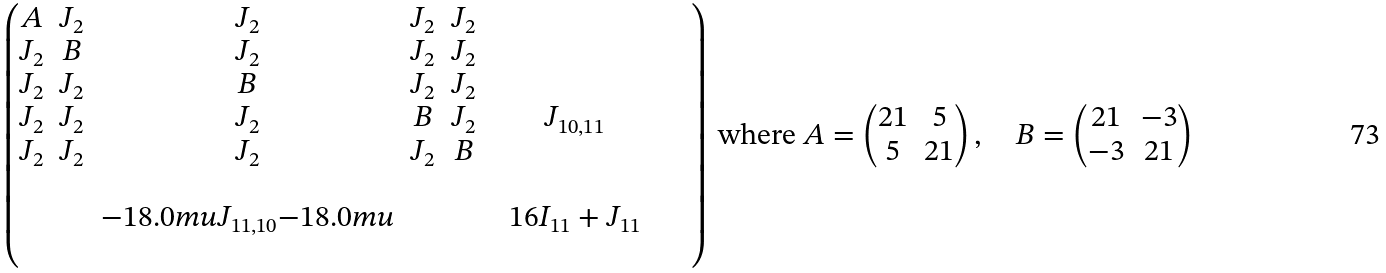Convert formula to latex. <formula><loc_0><loc_0><loc_500><loc_500>\begin{pmatrix} A & J _ { 2 } & J _ { 2 } & J _ { 2 } & J _ { 2 } & & & \\ J _ { 2 } & B & J _ { 2 } & J _ { 2 } & J _ { 2 } & & & \\ J _ { 2 } & J _ { 2 } & B & J _ { 2 } & J _ { 2 } & & & \\ J _ { 2 } & J _ { 2 } & J _ { 2 } & B & J _ { 2 } & & J _ { 1 0 , 1 1 } & \\ J _ { 2 } & J _ { 2 } & J _ { 2 } & J _ { 2 } & B & & & \\ & & & & & & & & & \\ & & { - 1 8 . 0 m u } J _ { 1 1 , 1 0 } { - 1 8 . 0 m u } & & & & 1 6 I _ { 1 1 } + J _ { 1 1 } & \\ & & & & & & & & & \\ \end{pmatrix} \text { where } A = \begin{pmatrix} 2 1 & 5 \\ 5 & 2 1 \end{pmatrix} , \quad B = \begin{pmatrix} 2 1 & - 3 \\ - 3 & 2 1 \end{pmatrix}</formula> 